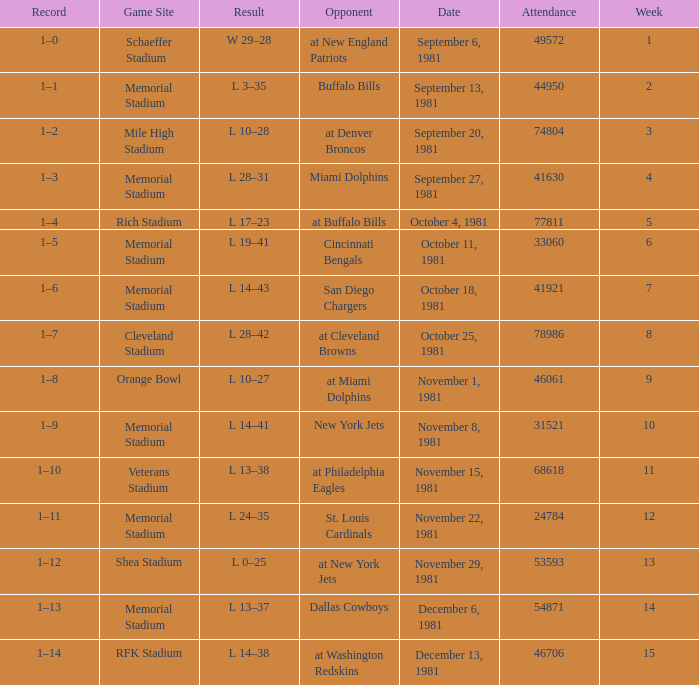When it is week 2 what is the record? 1–1. 